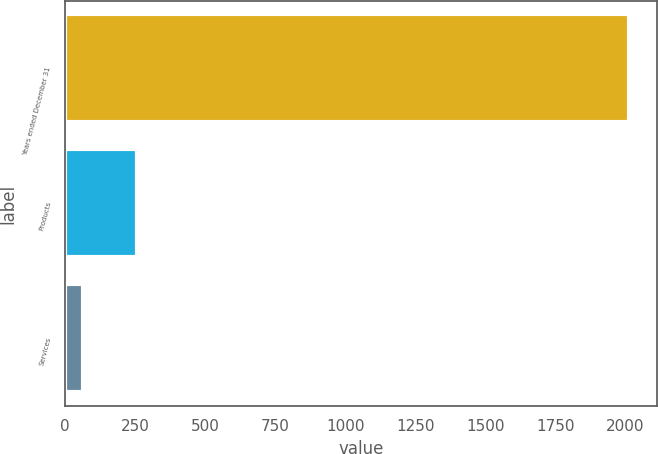Convert chart. <chart><loc_0><loc_0><loc_500><loc_500><bar_chart><fcel>Years ended December 31<fcel>Products<fcel>Services<nl><fcel>2012<fcel>257.9<fcel>63<nl></chart> 